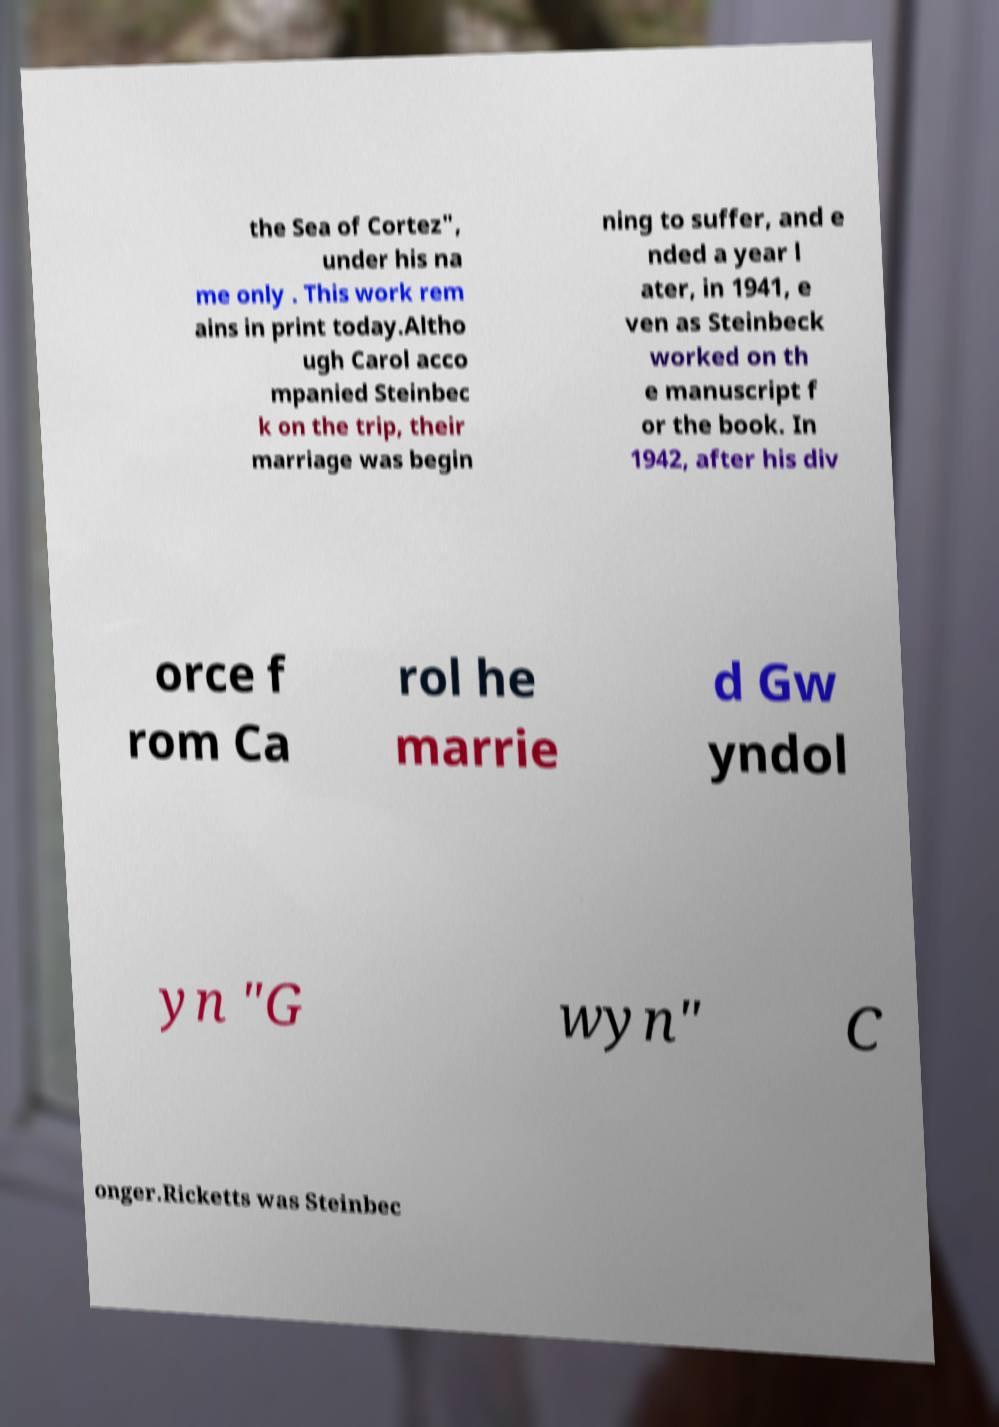There's text embedded in this image that I need extracted. Can you transcribe it verbatim? the Sea of Cortez", under his na me only . This work rem ains in print today.Altho ugh Carol acco mpanied Steinbec k on the trip, their marriage was begin ning to suffer, and e nded a year l ater, in 1941, e ven as Steinbeck worked on th e manuscript f or the book. In 1942, after his div orce f rom Ca rol he marrie d Gw yndol yn "G wyn" C onger.Ricketts was Steinbec 